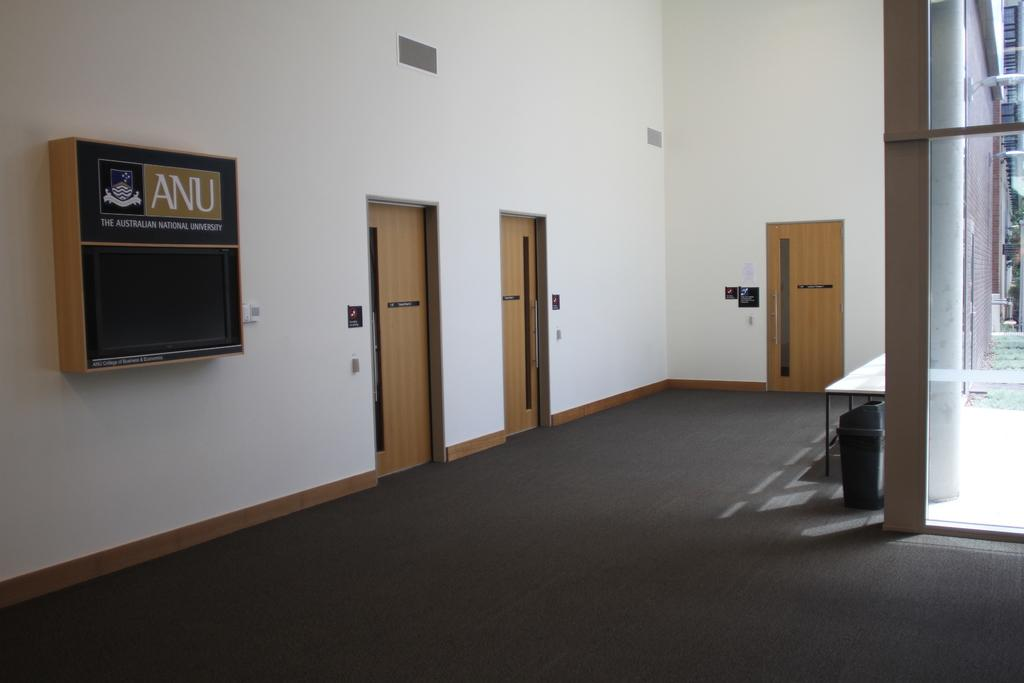What type of floor covering is visible in the image? There is a carpet in the image. What is located above the carpet? There is a table above the carpet. What type of architectural features can be seen in the image? Doors and walls are visible in the image. What decorative items are present on the walls? There are posters and a box on the wall. Can you see a drain in the image? There is no drain present in the image. What type of truck is visible in the image? There is no truck present in the image. 